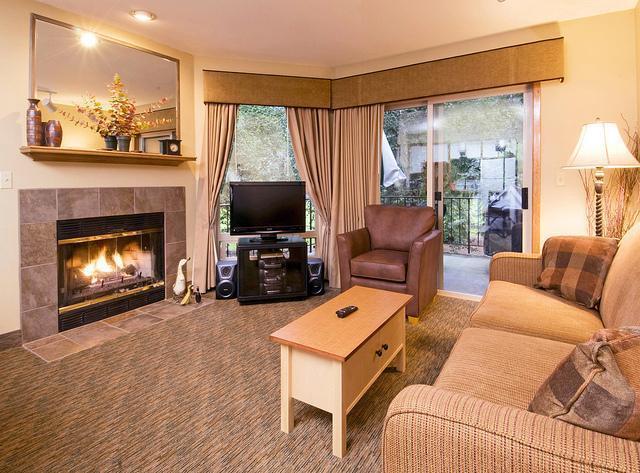How many tvs can you see?
Give a very brief answer. 1. How many people in the photo?
Give a very brief answer. 0. 